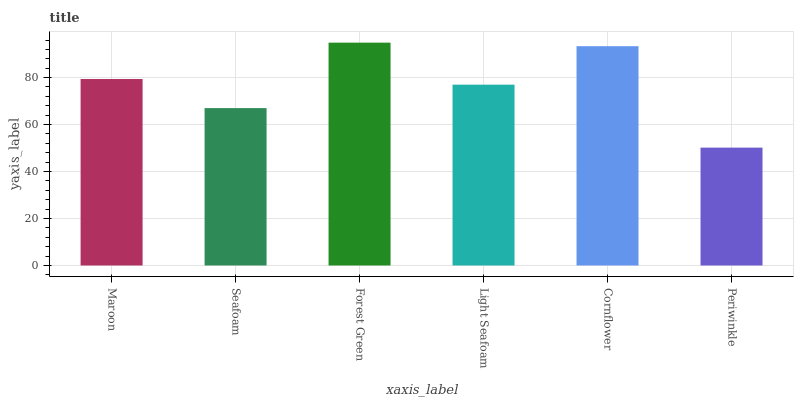Is Periwinkle the minimum?
Answer yes or no. Yes. Is Forest Green the maximum?
Answer yes or no. Yes. Is Seafoam the minimum?
Answer yes or no. No. Is Seafoam the maximum?
Answer yes or no. No. Is Maroon greater than Seafoam?
Answer yes or no. Yes. Is Seafoam less than Maroon?
Answer yes or no. Yes. Is Seafoam greater than Maroon?
Answer yes or no. No. Is Maroon less than Seafoam?
Answer yes or no. No. Is Maroon the high median?
Answer yes or no. Yes. Is Light Seafoam the low median?
Answer yes or no. Yes. Is Seafoam the high median?
Answer yes or no. No. Is Cornflower the low median?
Answer yes or no. No. 